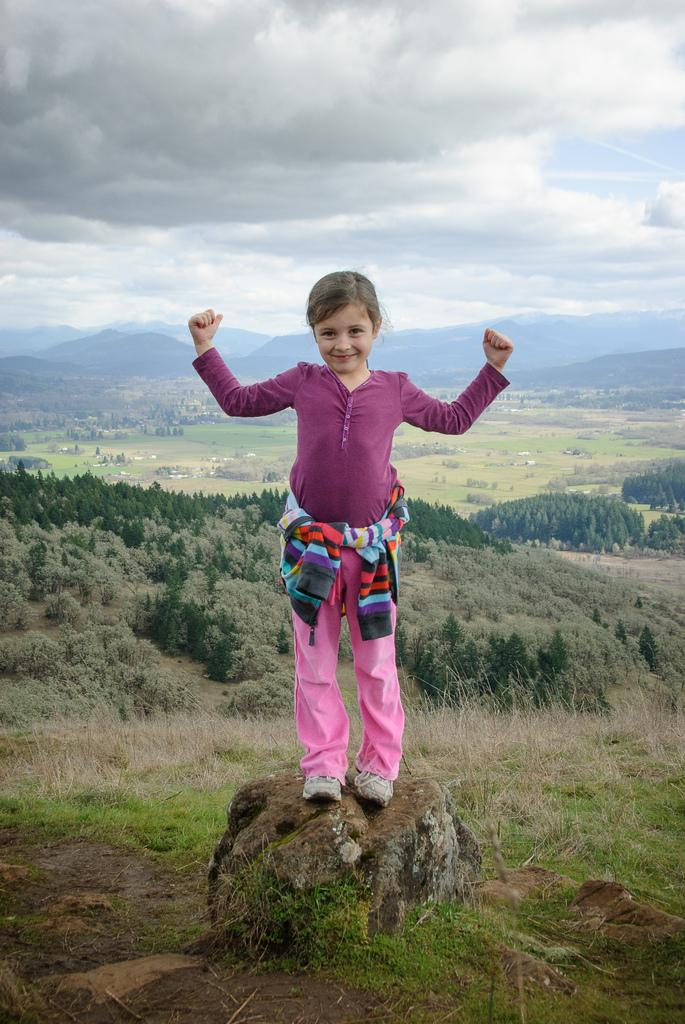What is the girl in the image standing on? The girl is standing on a stone. What can be seen in the background of the image? There are trees and small plants in the background of the image. What is visible at the top of the image? The sky is visible at the top of the image. What can be observed in the sky? There are clouds in the sky. What type of landscape feature is visible at the backside of the image? There are hills visible at the backside of the image. Does the girl have a tail in the image? No, the girl does not have a tail in the image. What type of glass object can be seen on the stone? There is no glass object present in the image. 